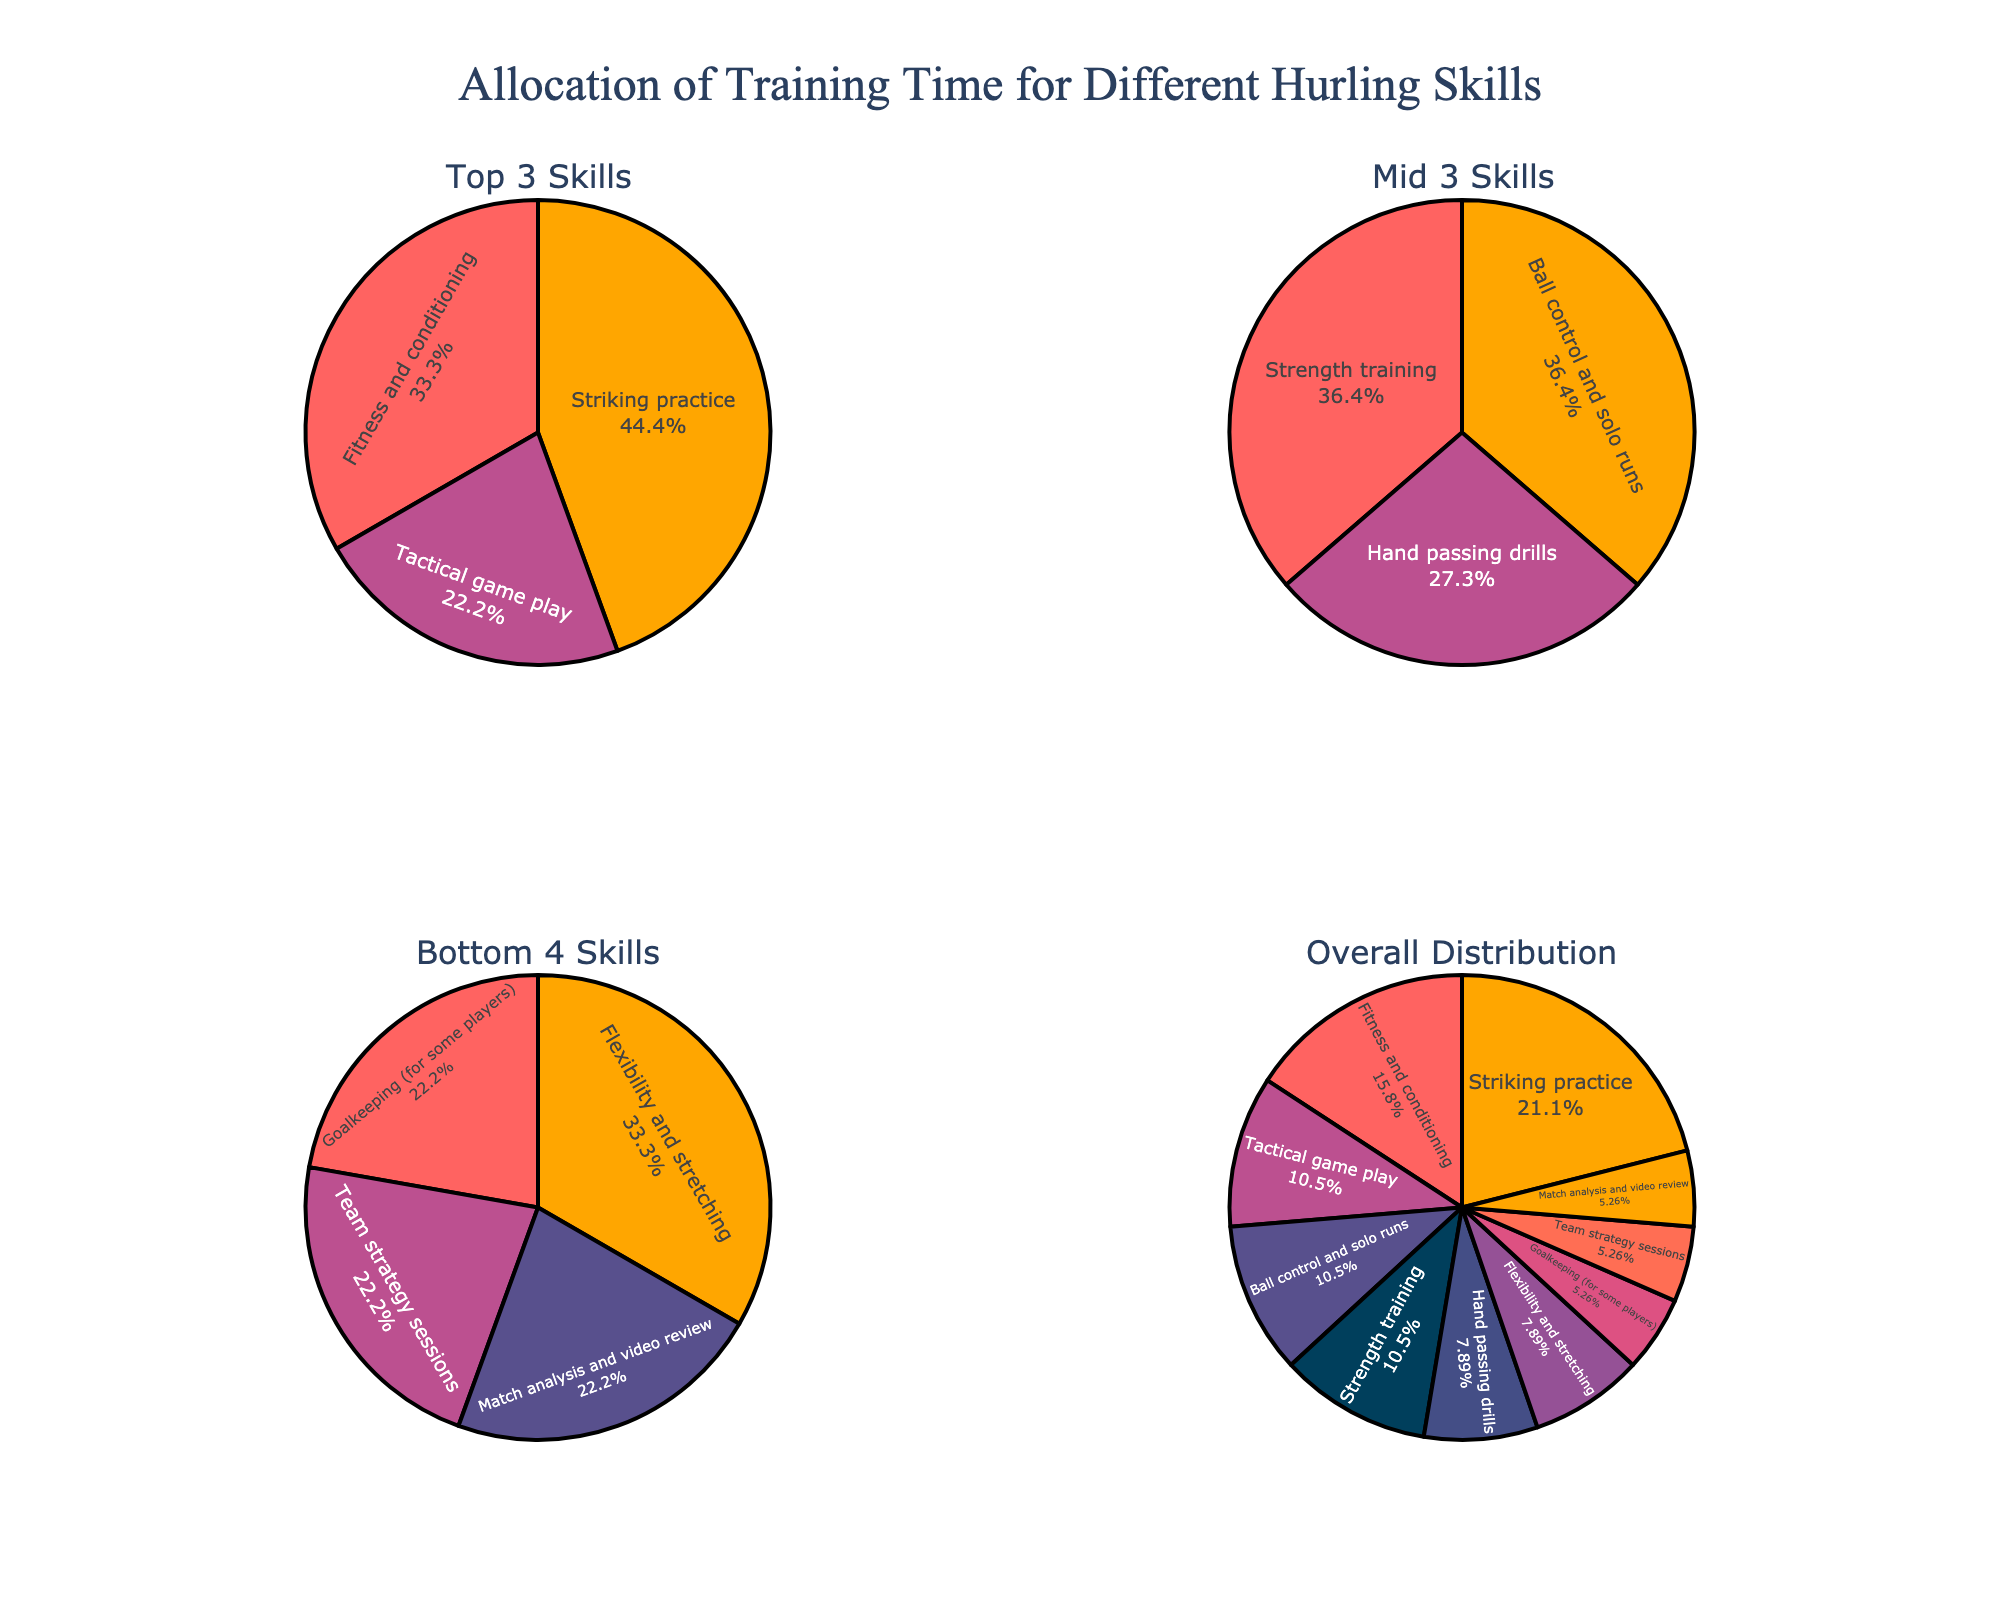What is the title of the figure? The title of the figure is displayed at the top and reads "Performance Benchmarks of Wicket Application Components."
Answer: Performance Benchmarks of Wicket Application Components Which component has the highest response time at a load of 750? According to the plot, under a load of 750, "UserProfilePage" has a response time of 1100 ms, which is higher than the other components.
Answer: UserProfilePage How does the throughput change for HomePage as the load increases from 100 to 1000? For HomePage, the throughput decreases from 450 at a load of 100 to 180 at a load of 1000.
Answer: Decreases Compare the response times of HomePage and LoginPage at a load of 500. Which one is higher? At a load of 500, HomePage has a response time of 580 ms and LoginPage has 350 ms. Therefore, HomePage's response time is higher.
Answer: HomePage Calculate the average response time of SearchResultsPage for all load conditions. The response times for SearchResultsPage are 180, 380, 650, 980, and 1380. The average is calculated as (180 + 380 + 650 + 980 + 1380) / 5 = 714 ms.
Answer: 714 Which component shows the most significant decrease in throughput as load increases from 100 to 1000? All components show a decrease in throughput, but "UserProfilePage" shows the most significant drop from 400 to 160.
Answer: UserProfilePage What is the trend of response times for UserProfilePage as the load increases? For UserProfilePage, the response time consistently increases as the load increases from 100 to 1000.
Answer: Increases Among all components, which one maintains the highest throughput under a load of 250? At a load of 250, LoginPage maintains the highest throughput of 520.
Answer: LoginPage Comparing all components, which one takes the longest to respond under a load of 1000? At a load of 1000, "UserProfilePage" takes the longest to respond with a response time of 1550 ms.
Answer: UserProfilePage 